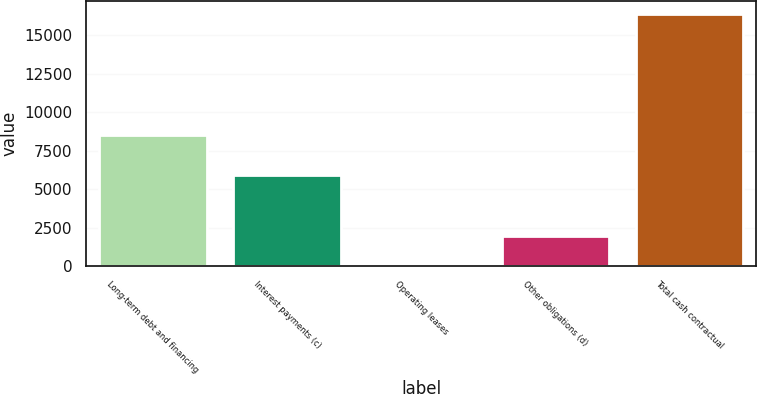Convert chart to OTSL. <chart><loc_0><loc_0><loc_500><loc_500><bar_chart><fcel>Long-term debt and financing<fcel>Interest payments (c)<fcel>Operating leases<fcel>Other obligations (d)<fcel>Total cash contractual<nl><fcel>8509<fcel>5907<fcel>45<fcel>1932<fcel>16393<nl></chart> 